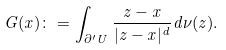Convert formula to latex. <formula><loc_0><loc_0><loc_500><loc_500>G ( x ) \colon = \int _ { \partial ^ { \prime } U } \frac { z - x } { | z - x | ^ { d } } d \nu ( z ) .</formula> 